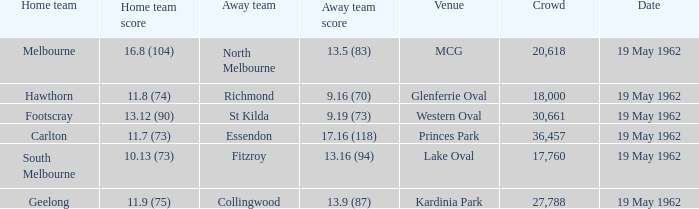What is the away team's score when the home team scores 16.8 (104)? 13.5 (83). 